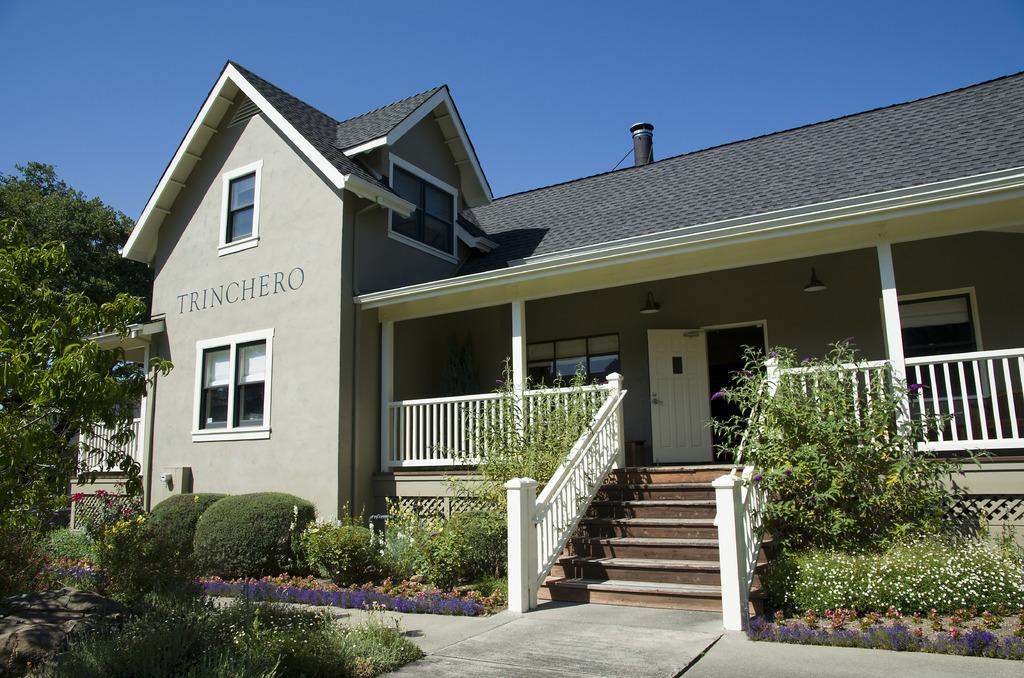What type of vegetation can be seen in the image? There are trees, bushes, and plants in the image. What type of structure is present in the image? There is a house in the image. What is visible in the background of the image? The sky is visible in the background of the image. What type of bucket is being used by the writer in the image? There is no writer or bucket present in the image. What type of paste is being applied to the plants in the image? There is no paste being applied to the plants in the image. 